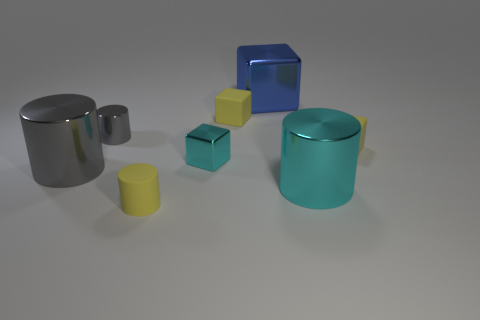There is a large cylinder that is the same color as the tiny shiny cylinder; what material is it?
Your response must be concise. Metal. What number of small objects are either gray metal objects or yellow matte cylinders?
Make the answer very short. 2. The small rubber cylinder has what color?
Offer a very short reply. Yellow. Are there any tiny yellow matte cubes on the left side of the tiny yellow object that is to the right of the blue shiny object?
Ensure brevity in your answer.  Yes. Is the number of tiny gray cylinders that are in front of the large gray thing less than the number of tiny yellow blocks?
Offer a terse response. Yes. Is the large object left of the yellow matte cylinder made of the same material as the tiny gray thing?
Your answer should be very brief. Yes. What is the color of the small block that is the same material as the big gray cylinder?
Offer a terse response. Cyan. Is the number of tiny blocks that are behind the large blue block less than the number of things that are behind the tiny shiny cylinder?
Offer a very short reply. Yes. Do the shiny cylinder behind the cyan metallic cube and the large cylinder that is left of the tiny metallic cube have the same color?
Make the answer very short. Yes. Is there a big gray cylinder that has the same material as the large block?
Provide a short and direct response. Yes. 